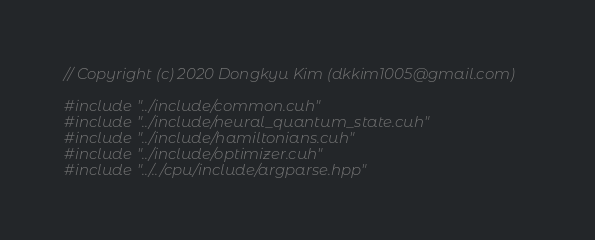Convert code to text. <code><loc_0><loc_0><loc_500><loc_500><_Cuda_>// Copyright (c) 2020 Dongkyu Kim (dkkim1005@gmail.com)

#include "../include/common.cuh"
#include "../include/neural_quantum_state.cuh"
#include "../include/hamiltonians.cuh"
#include "../include/optimizer.cuh"
#include "../../cpu/include/argparse.hpp"
</code> 